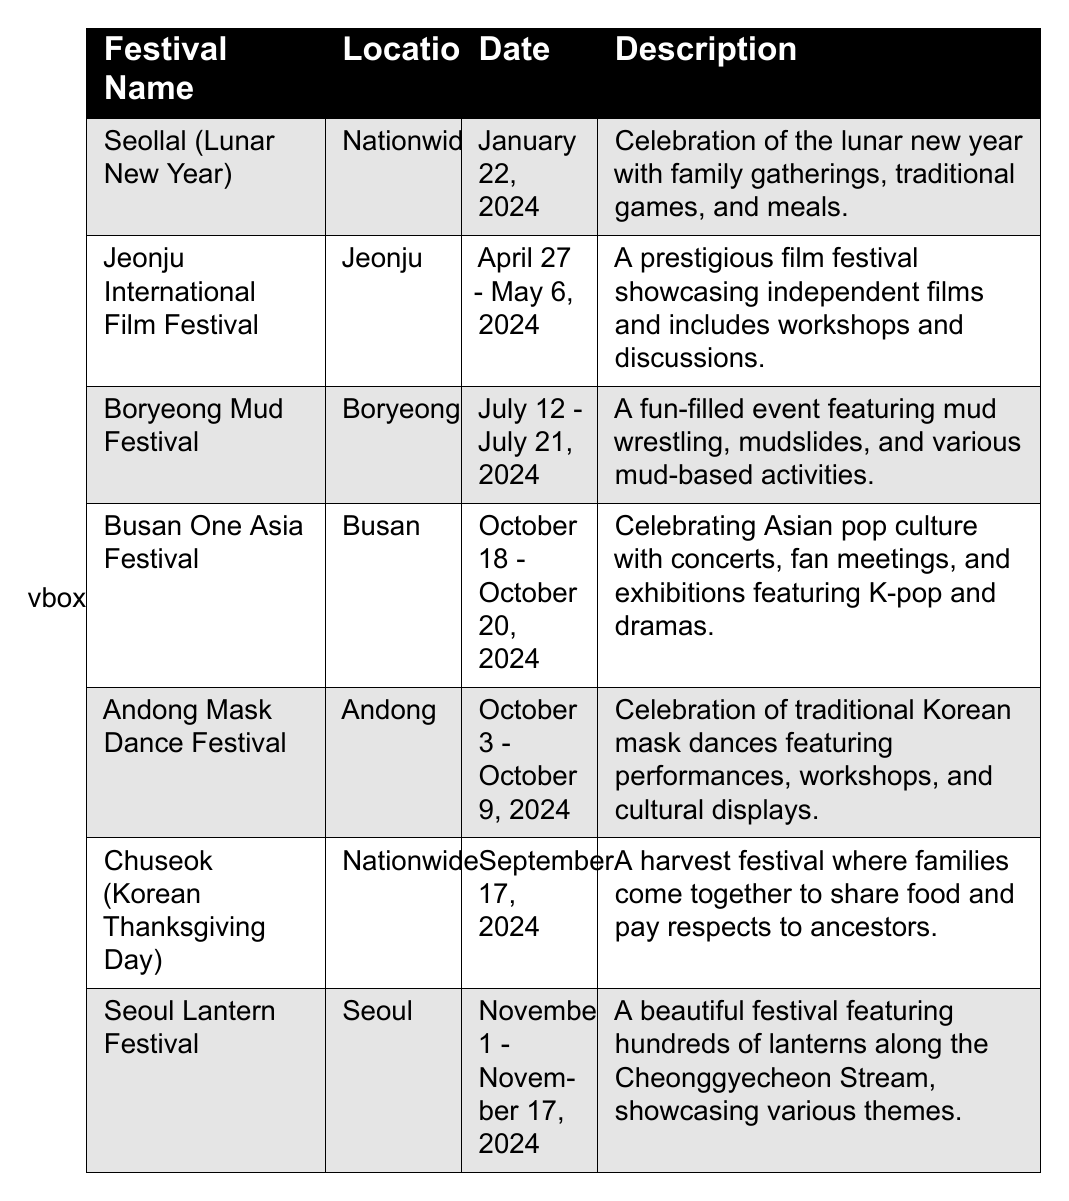What is the date of the Seollal (Lunar New Year) festival? The table lists the date of the Seollal (Lunar New Year) festival as January 22, 2024.
Answer: January 22, 2024 Where is the Boryeong Mud Festival held? According to the table, the Boryeong Mud Festival takes place in Boryeong.
Answer: Boryeong Which festival celebrates Asian pop culture? The table indicates that the Busan One Asia Festival celebrates Asian pop culture with various events.
Answer: Busan One Asia Festival How many days does the Jeonju International Film Festival last? The Jeonju International Film Festival is held from April 27 to May 6, 2024, which is a total of 10 days.
Answer: 10 days Is the Seoul Lantern Festival held in October? The table shows that the Seoul Lantern Festival runs from November 1 to November 17, 2024, so it is not held in October.
Answer: No What is the shared significance of Chuseok and Seollal? Both Chuseok and Seollal are nationwide festivals celebrated with family gatherings and meals, highlighting respect for culture and traditions.
Answer: Family gatherings Which festival occurs last in the year? The table provides dates for several festivals, and the Seoul Lantern Festival, occurring from November 1 to November 17, 2024, is the last festival listed.
Answer: Seoul Lantern Festival How many festivals are celebrated nationwide? The table lists two festivals, Seollal (Lunar New Year) and Chuseok (Korean Thanksgiving Day), as being celebrated nationwide.
Answer: 2 festivals What is the duration of the Boryeong Mud Festival compared to the Andong Mask Dance Festival? The Boryeong Mud Festival lasts from July 12 to July 21, 2024 (10 days), while the Andong Mask Dance Festival lasts from October 3 to October 9, 2024 (7 days), making the Boryeong Mud Festival 3 days longer.
Answer: Boryeong Mud Festival is 3 days longer Which festival features mud-related activities? The Boryeong Mud Festival is specifically known for activities like mud wrestling and mudslides, as highlighted in the table's description.
Answer: Boryeong Mud Festival What is the significance of the Andong Mask Dance Festival? The table states that the Andong Mask Dance Festival celebrates traditional Korean mask dances with various performances and cultural displays.
Answer: Traditional Korean mask dances 